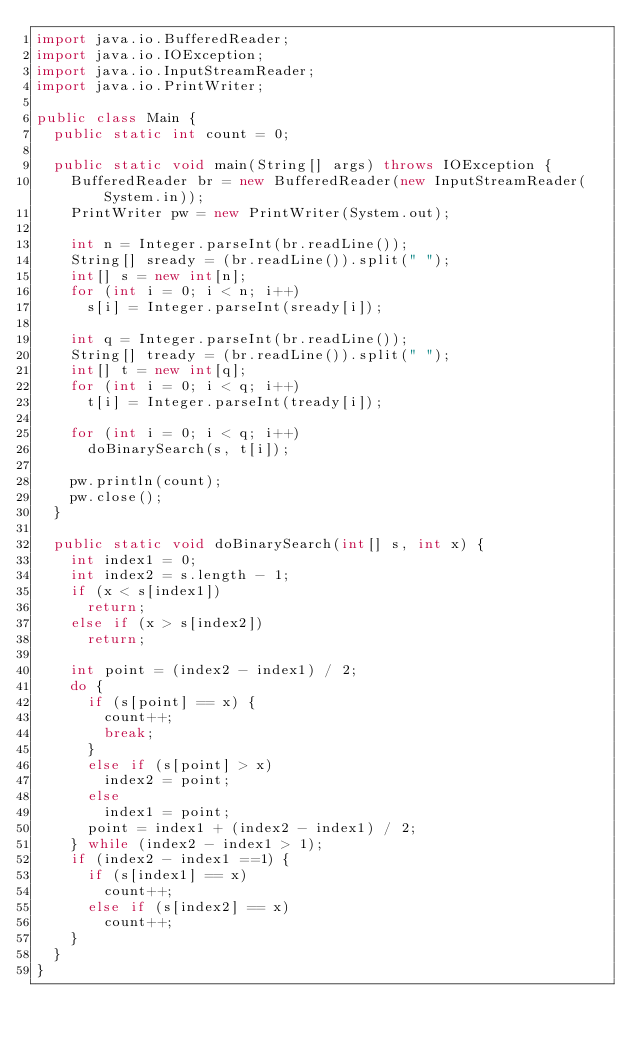<code> <loc_0><loc_0><loc_500><loc_500><_Java_>import java.io.BufferedReader;
import java.io.IOException;
import java.io.InputStreamReader;
import java.io.PrintWriter;

public class Main {
	public static int count = 0;
	
	public static void main(String[] args) throws IOException {
		BufferedReader br = new BufferedReader(new InputStreamReader(System.in));
		PrintWriter pw = new PrintWriter(System.out);
		
		int n = Integer.parseInt(br.readLine());
		String[] sready = (br.readLine()).split(" ");
		int[] s = new int[n];
		for (int i = 0; i < n; i++)
			s[i] = Integer.parseInt(sready[i]);
		
		int q = Integer.parseInt(br.readLine());
		String[] tready = (br.readLine()).split(" ");
		int[] t = new int[q];
		for (int i = 0; i < q; i++)
			t[i] = Integer.parseInt(tready[i]);
		
		for (int i = 0; i < q; i++)
			doBinarySearch(s, t[i]);
		
		pw.println(count);
		pw.close();
	}
	
	public static void doBinarySearch(int[] s, int x) {
		int index1 = 0;
		int index2 = s.length - 1;
		if (x < s[index1])
			return;
		else if (x > s[index2])
			return;
		
		int point = (index2 - index1) / 2;
		do {
			if (s[point] == x) {
				count++;
				break;
			}
			else if (s[point] > x)
				index2 = point;
			else
				index1 = point;
			point = index1 + (index2 - index1) / 2;
		} while (index2 - index1 > 1);
		if (index2 - index1 ==1) {
			if (s[index1] == x)
				count++;
			else if (s[index2] == x)
				count++;
		}
	}
}</code> 